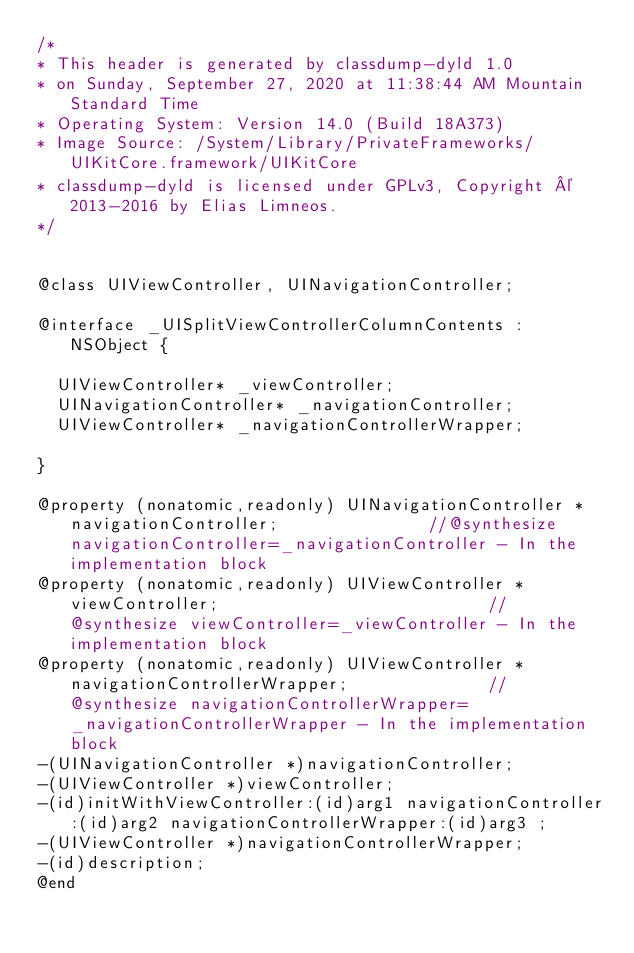<code> <loc_0><loc_0><loc_500><loc_500><_C_>/*
* This header is generated by classdump-dyld 1.0
* on Sunday, September 27, 2020 at 11:38:44 AM Mountain Standard Time
* Operating System: Version 14.0 (Build 18A373)
* Image Source: /System/Library/PrivateFrameworks/UIKitCore.framework/UIKitCore
* classdump-dyld is licensed under GPLv3, Copyright © 2013-2016 by Elias Limneos.
*/


@class UIViewController, UINavigationController;

@interface _UISplitViewControllerColumnContents : NSObject {

	UIViewController* _viewController;
	UINavigationController* _navigationController;
	UIViewController* _navigationControllerWrapper;

}

@property (nonatomic,readonly) UINavigationController * navigationController;               //@synthesize navigationController=_navigationController - In the implementation block
@property (nonatomic,readonly) UIViewController * viewController;                           //@synthesize viewController=_viewController - In the implementation block
@property (nonatomic,readonly) UIViewController * navigationControllerWrapper;              //@synthesize navigationControllerWrapper=_navigationControllerWrapper - In the implementation block
-(UINavigationController *)navigationController;
-(UIViewController *)viewController;
-(id)initWithViewController:(id)arg1 navigationController:(id)arg2 navigationControllerWrapper:(id)arg3 ;
-(UIViewController *)navigationControllerWrapper;
-(id)description;
@end

</code> 